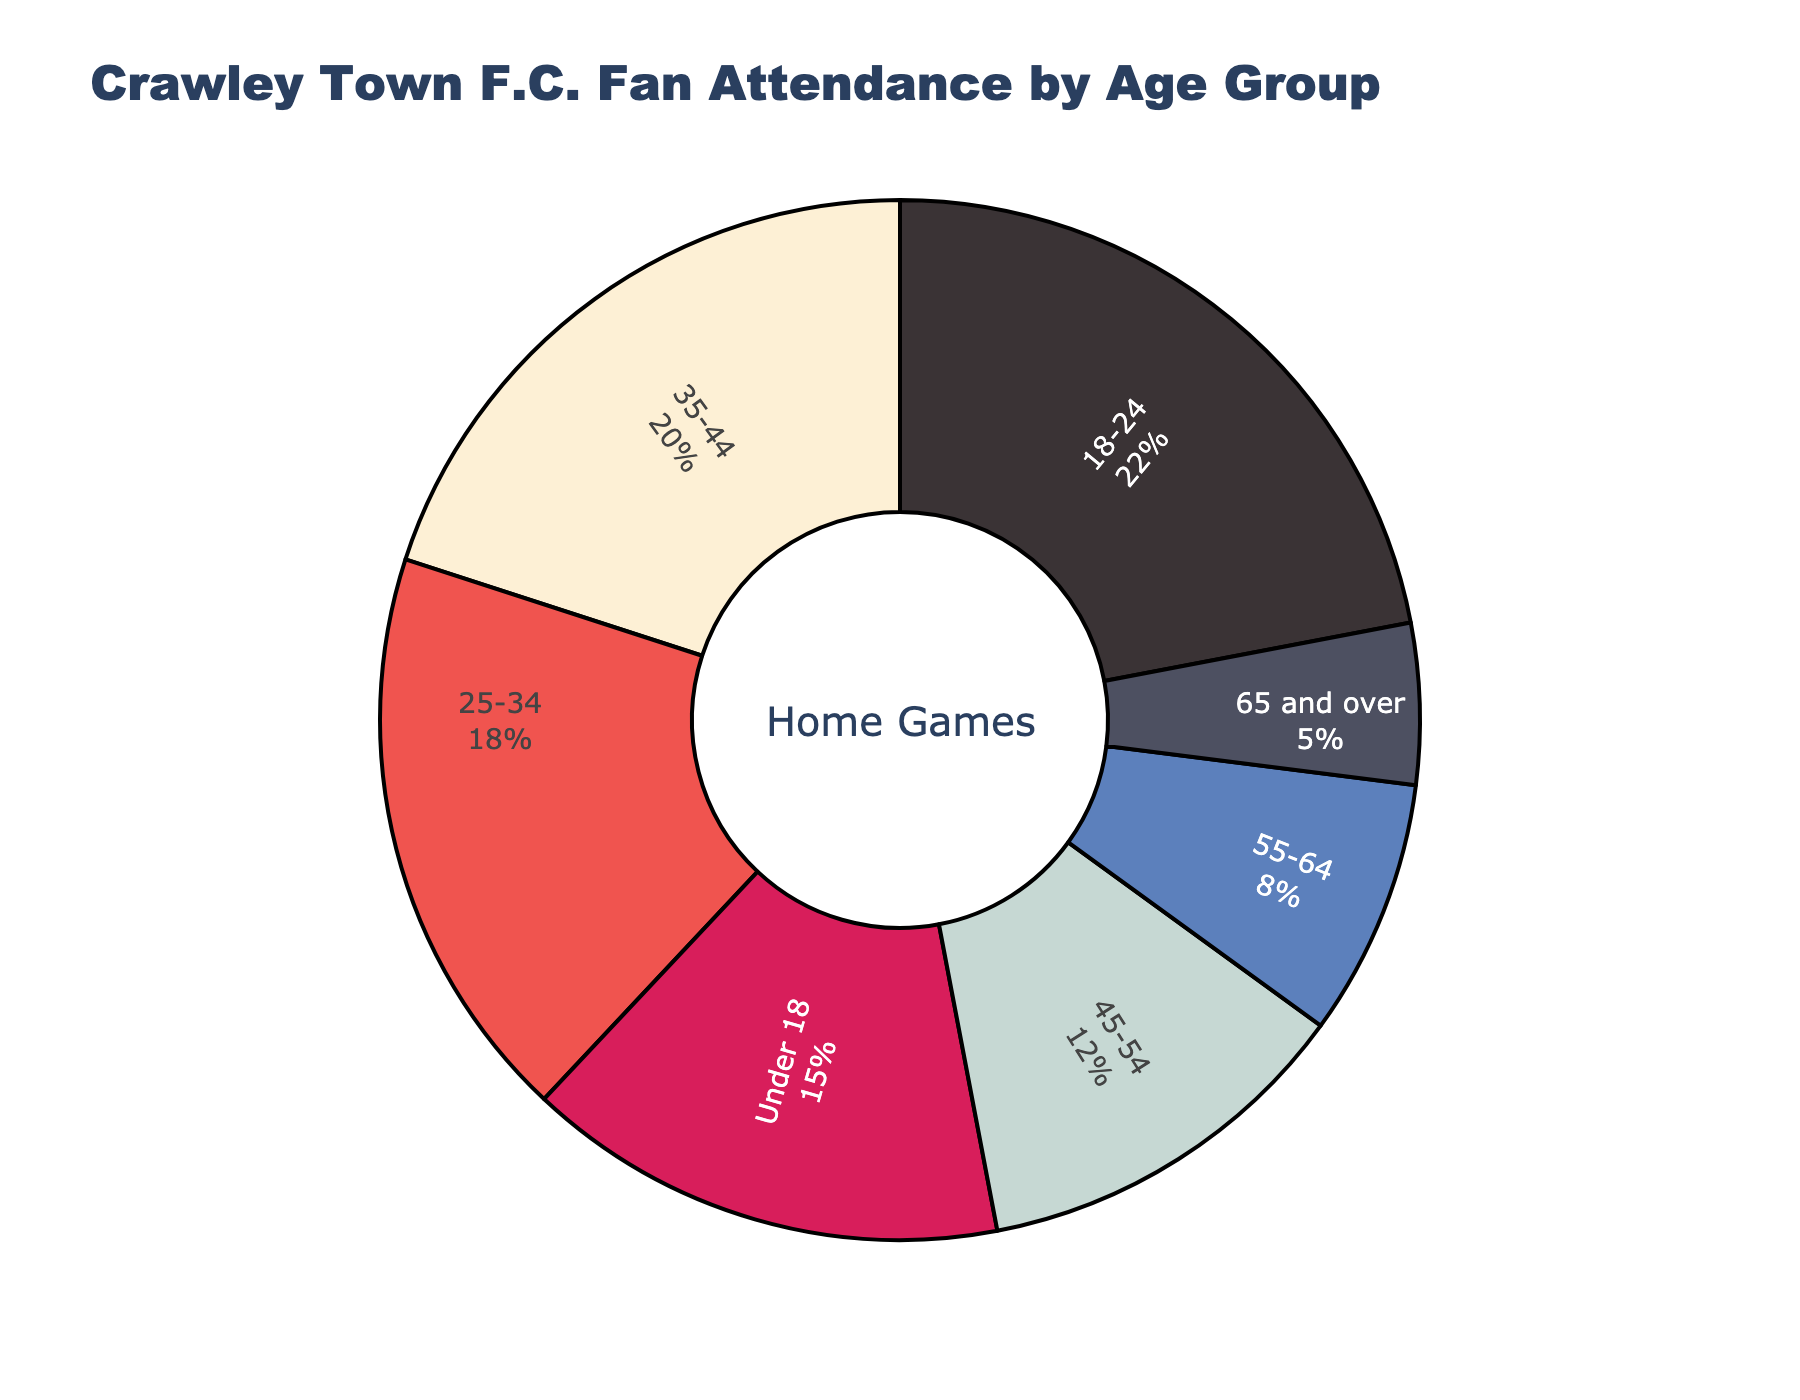Which age group has the highest fan attendance? The age groups and their respective percentages are displayed. The highest percentage corresponds to the group 18-24 with 22%.
Answer: 18-24 Which age group has the lowest fan attendance? The age groups and their respective percentages are displayed. The lowest percentage corresponds to the group 65 and over with 5%.
Answer: 65 and over What is the combined percentage of fans aged under 18 and 18-24? Add the percentages for the 'Under 18' group and the '18-24' group: 15% + 22% = 37%.
Answer: 37% How does the attendance percentage of the 35-44 group compare to that of the 45-54 group? The percentage for the 35-44 group is 20%, while for the 45-54 group, it is 12%. Thus, the 35-44 group has a higher attendance percentage.
Answer: 35-44 group has a higher percentage Which age group represents 8% of the fan attendance? Look at the figure to find 8%, which corresponds to the 55-64 age group.
Answer: 55-64 What is the sum of the fan percentages for the age groups from 25 to 54? Add the percentages for the 25-34, 35-44, and 45-54 groups: 18% + 20% + 12% = 50%.
Answer: 50% How much greater is the fan attendance percentage for the 18-24 group compared to the 65 and over group? Subtract the percentage of the 65 and over group from the 18-24 group: 22% - 5% = 17%.
Answer: 17% What is the average percentage of fans for the groups under 18 and 55-64? Add the percentages for the 'Under 18' group and the '55-64' group then divide by 2: (15% + 8%) / 2 = 11.5%.
Answer: 11.5% Is there any age group with exactly half the attendance as the 18-24 group? The attendance percentage for the 18-24 group is 22%. Half of this is 11%. None of the displayed age groups have an 11% attendance.
Answer: No Which age group, represented by the light blue section, has what percentage of fan attendance? The light blue section represents the 55-64 group, which has 8% fan attendance.
Answer: 55-64, 8% 